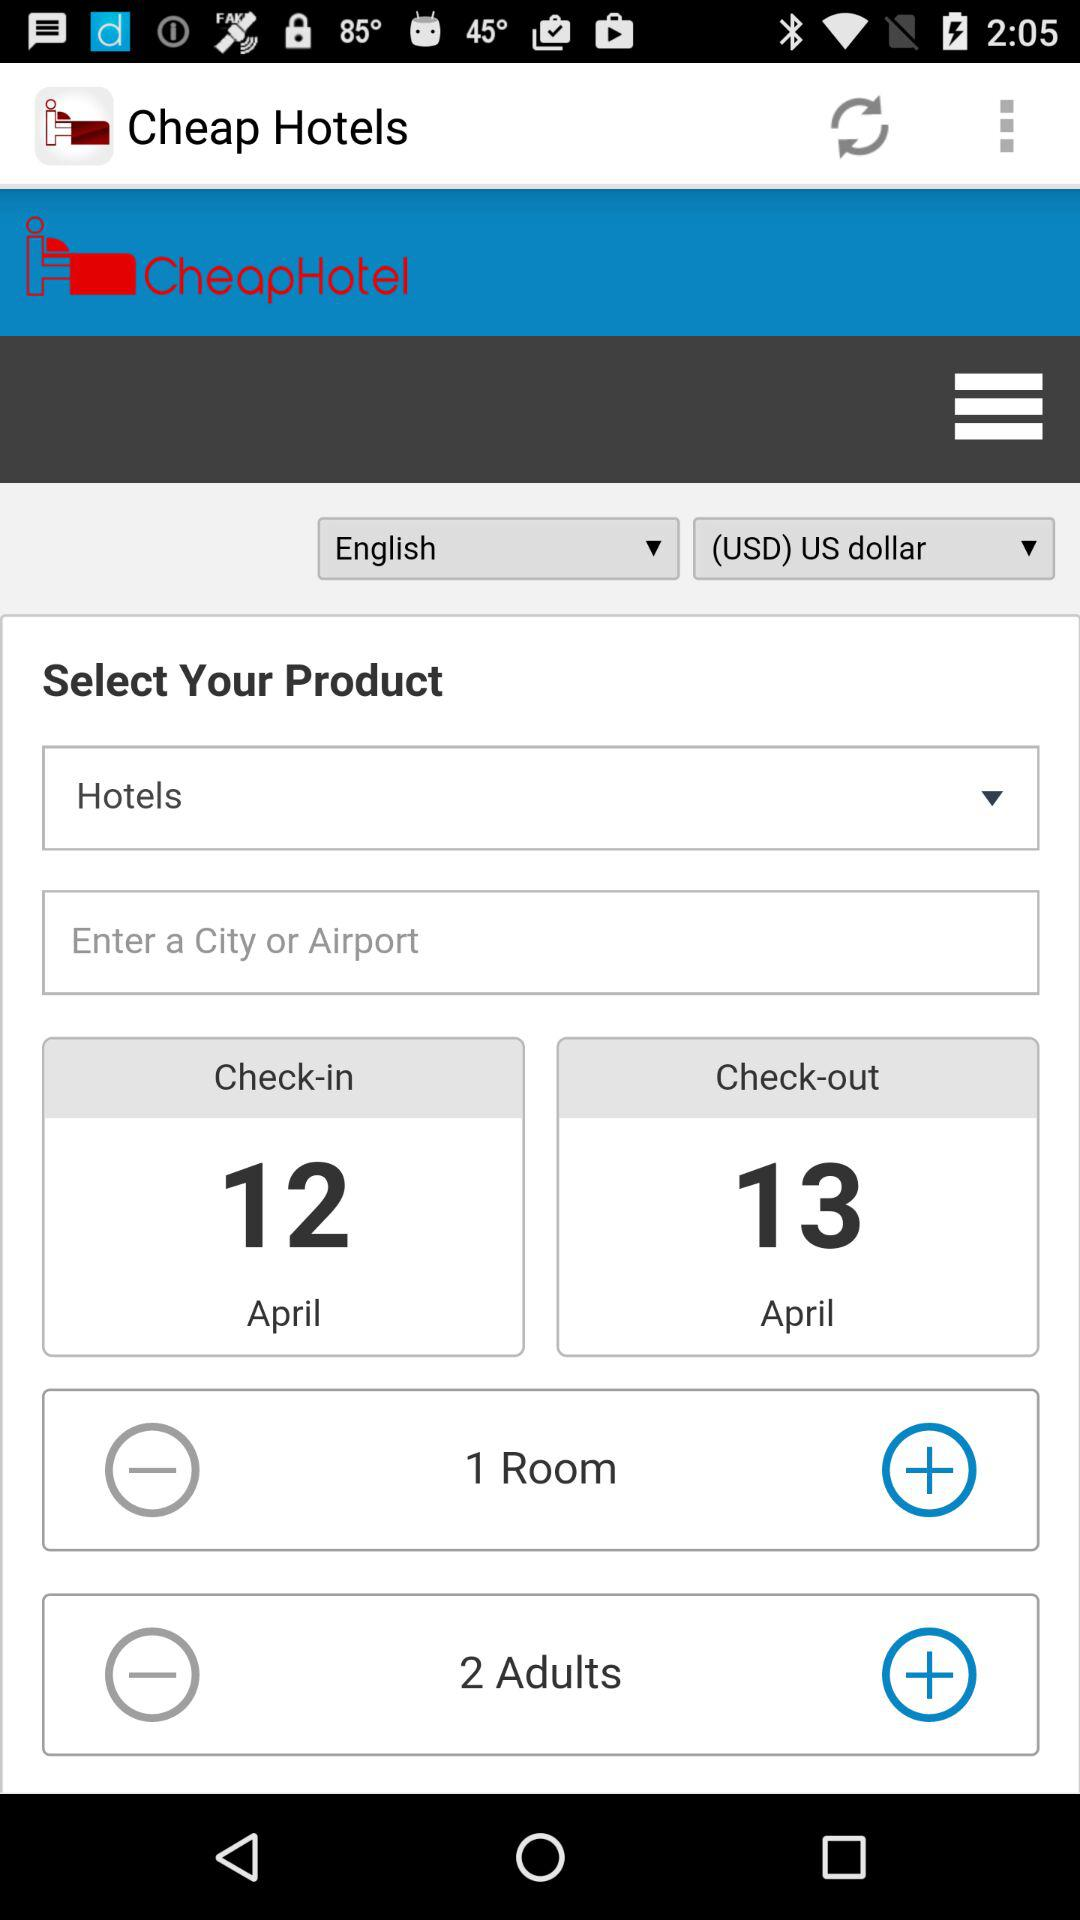Which currency is selected? The selected currency is the US dollar. 